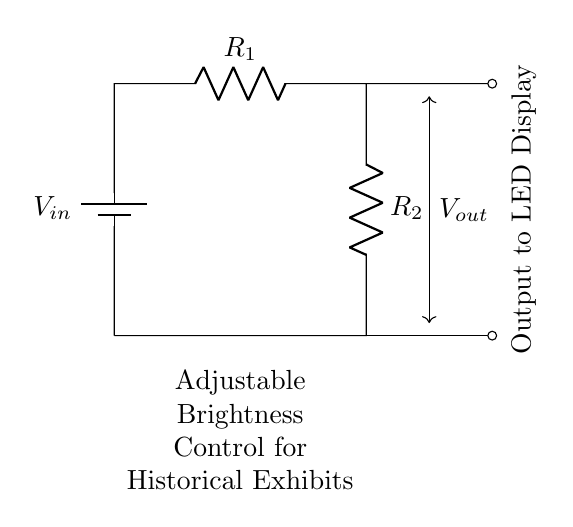What are the resistors in this circuit? The circuit diagram shows two resistors labeled R1 and R2. These resistors are part of the voltage divider configuration.
Answer: R1, R2 What is the purpose of this circuit? This circuit is an adjustable brightness control for LED displays, allowing for modification of the output voltage to regulate brightness.
Answer: Adjustable brightness control What is the relationship between the input voltage and the output voltage in a voltage divider? The output voltage is a fraction of the input voltage determined by the ratio of the two resistors R1 and R2, according to the formula Vout = Vin * R2 / (R1 + R2).
Answer: Fraction If the resistance of R1 is increased, what happens to Vout? Increasing R1 reduces the ratio of R2 to the total resistance (R1 + R2), resulting in a decrease in Vout.
Answer: Decrease What is the output voltage indicated in the diagram? There is no specific numerical value given for Vout in the diagram; it's represented visually as a connection point but is not labeled with a value.
Answer: Not specified What type of circuit is depicted here? The circuit illustrated is a voltage divider, which is specifically designed to divide the input voltage into a lower output voltage based on the resistance values.
Answer: Voltage divider 